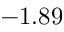<formula> <loc_0><loc_0><loc_500><loc_500>- 1 . 8 9</formula> 